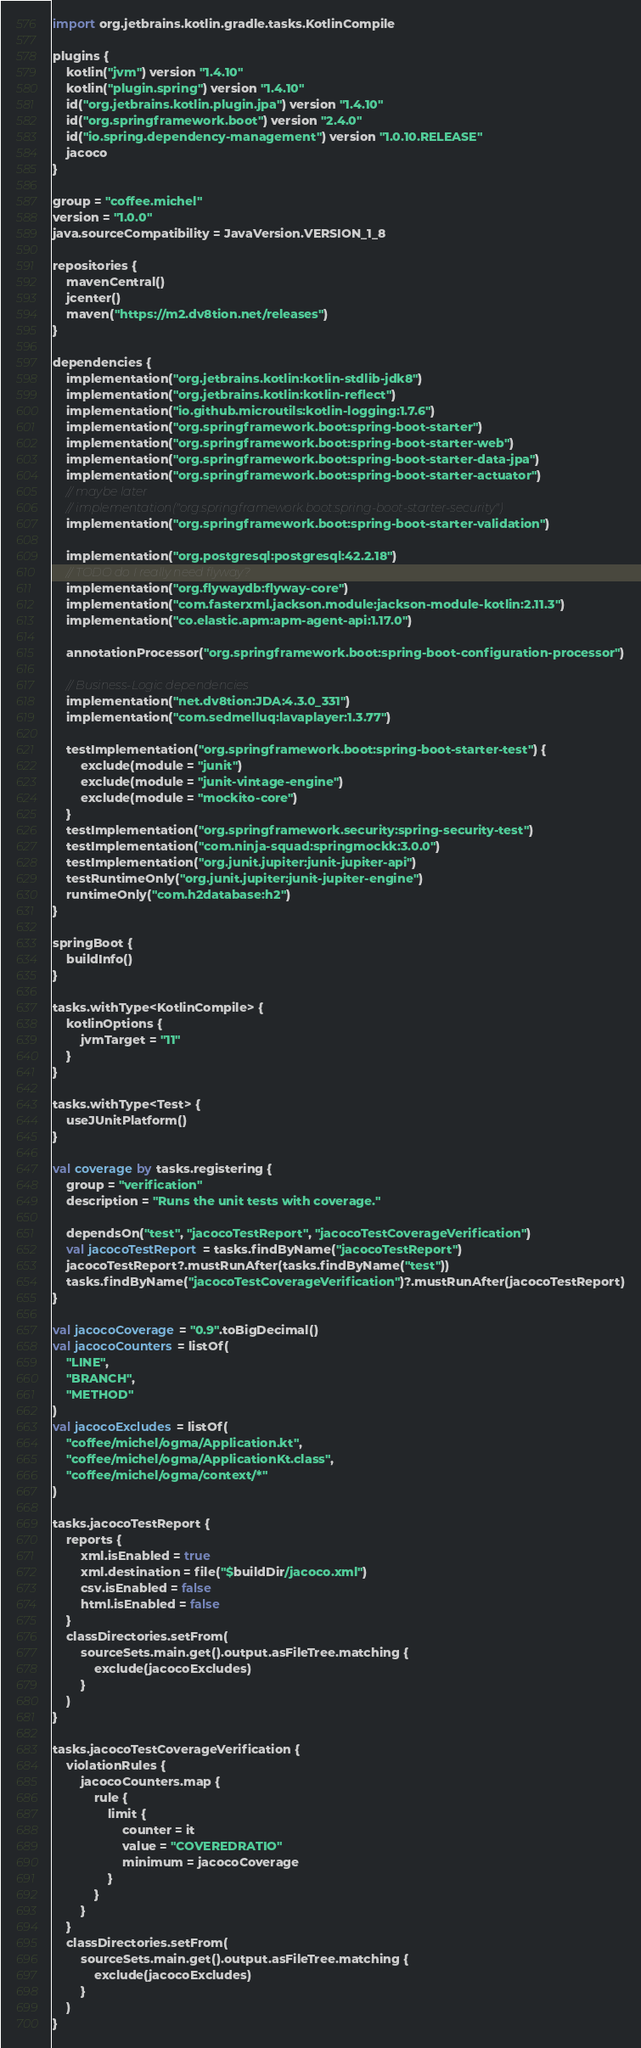<code> <loc_0><loc_0><loc_500><loc_500><_Kotlin_>import org.jetbrains.kotlin.gradle.tasks.KotlinCompile

plugins {
    kotlin("jvm") version "1.4.10"
    kotlin("plugin.spring") version "1.4.10"
    id("org.jetbrains.kotlin.plugin.jpa") version "1.4.10"
    id("org.springframework.boot") version "2.4.0"
    id("io.spring.dependency-management") version "1.0.10.RELEASE"
    jacoco
}

group = "coffee.michel"
version = "1.0.0"
java.sourceCompatibility = JavaVersion.VERSION_1_8

repositories {
    mavenCentral()
    jcenter()
    maven("https://m2.dv8tion.net/releases")
}

dependencies {
    implementation("org.jetbrains.kotlin:kotlin-stdlib-jdk8")
    implementation("org.jetbrains.kotlin:kotlin-reflect")
    implementation("io.github.microutils:kotlin-logging:1.7.6")
    implementation("org.springframework.boot:spring-boot-starter")
    implementation("org.springframework.boot:spring-boot-starter-web")
    implementation("org.springframework.boot:spring-boot-starter-data-jpa")
    implementation("org.springframework.boot:spring-boot-starter-actuator")
    // maybe later
    // implementation("org.springframework.boot:spring-boot-starter-security")
    implementation("org.springframework.boot:spring-boot-starter-validation")

    implementation("org.postgresql:postgresql:42.2.18")
    // TODO do I really need flyway?
    implementation("org.flywaydb:flyway-core")
    implementation("com.fasterxml.jackson.module:jackson-module-kotlin:2.11.3")
    implementation("co.elastic.apm:apm-agent-api:1.17.0")

    annotationProcessor("org.springframework.boot:spring-boot-configuration-processor")

    // Business-Logic dependencies
    implementation("net.dv8tion:JDA:4.3.0_331")
    implementation("com.sedmelluq:lavaplayer:1.3.77")

    testImplementation("org.springframework.boot:spring-boot-starter-test") {
        exclude(module = "junit")
        exclude(module = "junit-vintage-engine")
        exclude(module = "mockito-core")
    }
    testImplementation("org.springframework.security:spring-security-test")
    testImplementation("com.ninja-squad:springmockk:3.0.0")
    testImplementation("org.junit.jupiter:junit-jupiter-api")
    testRuntimeOnly("org.junit.jupiter:junit-jupiter-engine")
    runtimeOnly("com.h2database:h2")
}

springBoot {
    buildInfo()
}

tasks.withType<KotlinCompile> {
    kotlinOptions {
        jvmTarget = "11"
    }
}

tasks.withType<Test> {
    useJUnitPlatform()
}

val coverage by tasks.registering {
    group = "verification"
    description = "Runs the unit tests with coverage."

    dependsOn("test", "jacocoTestReport", "jacocoTestCoverageVerification")
    val jacocoTestReport = tasks.findByName("jacocoTestReport")
    jacocoTestReport?.mustRunAfter(tasks.findByName("test"))
    tasks.findByName("jacocoTestCoverageVerification")?.mustRunAfter(jacocoTestReport)
}

val jacocoCoverage = "0.9".toBigDecimal()
val jacocoCounters = listOf(
    "LINE",
    "BRANCH",
    "METHOD"
)
val jacocoExcludes = listOf(
    "coffee/michel/ogma/Application.kt",
    "coffee/michel/ogma/ApplicationKt.class",
    "coffee/michel/ogma/context/*"
)

tasks.jacocoTestReport {
    reports {
        xml.isEnabled = true
        xml.destination = file("$buildDir/jacoco.xml")
        csv.isEnabled = false
        html.isEnabled = false
    }
    classDirectories.setFrom(
        sourceSets.main.get().output.asFileTree.matching {
            exclude(jacocoExcludes)
        }
    )
}

tasks.jacocoTestCoverageVerification {
    violationRules {
        jacocoCounters.map {
            rule {
                limit {
                    counter = it
                    value = "COVEREDRATIO"
                    minimum = jacocoCoverage
                }
            }
        }
    }
    classDirectories.setFrom(
        sourceSets.main.get().output.asFileTree.matching {
            exclude(jacocoExcludes)
        }
    )
}
</code> 